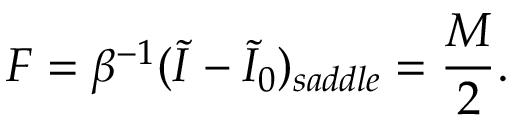Convert formula to latex. <formula><loc_0><loc_0><loc_500><loc_500>F = \beta ^ { - 1 } ( \widetilde { I } - \widetilde { I } _ { 0 } ) _ { s a d d l e } = { \frac { M } { 2 } } .</formula> 